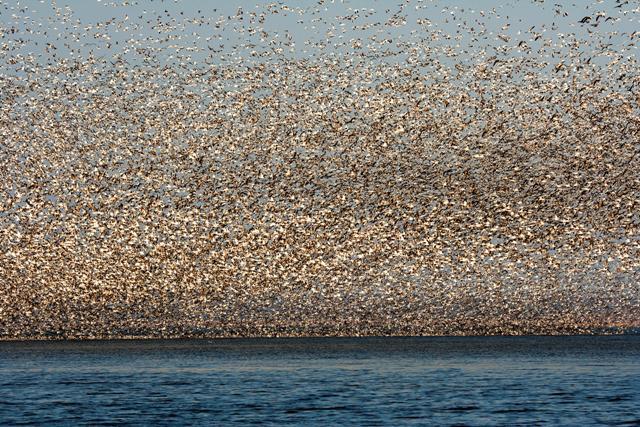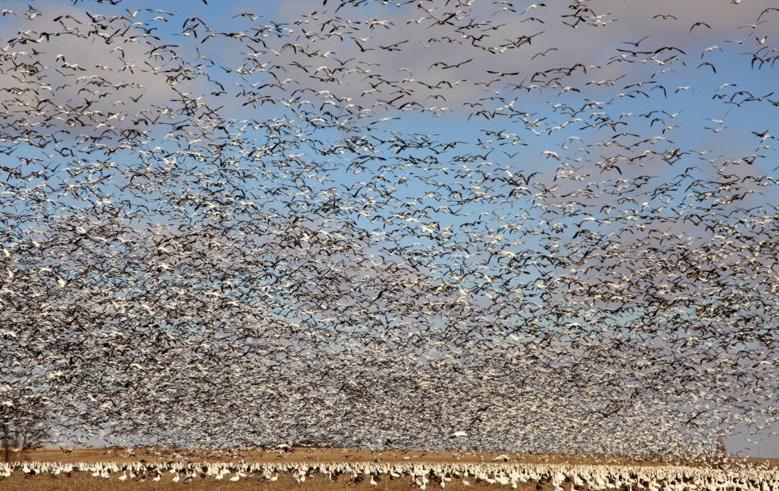The first image is the image on the left, the second image is the image on the right. Analyze the images presented: Is the assertion "A body of water is visible below a sky full of birds in at least one image." valid? Answer yes or no. Yes. The first image is the image on the left, the second image is the image on the right. Evaluate the accuracy of this statement regarding the images: "A very large flock of birds is seen flying over water in at least one of the images.". Is it true? Answer yes or no. Yes. 